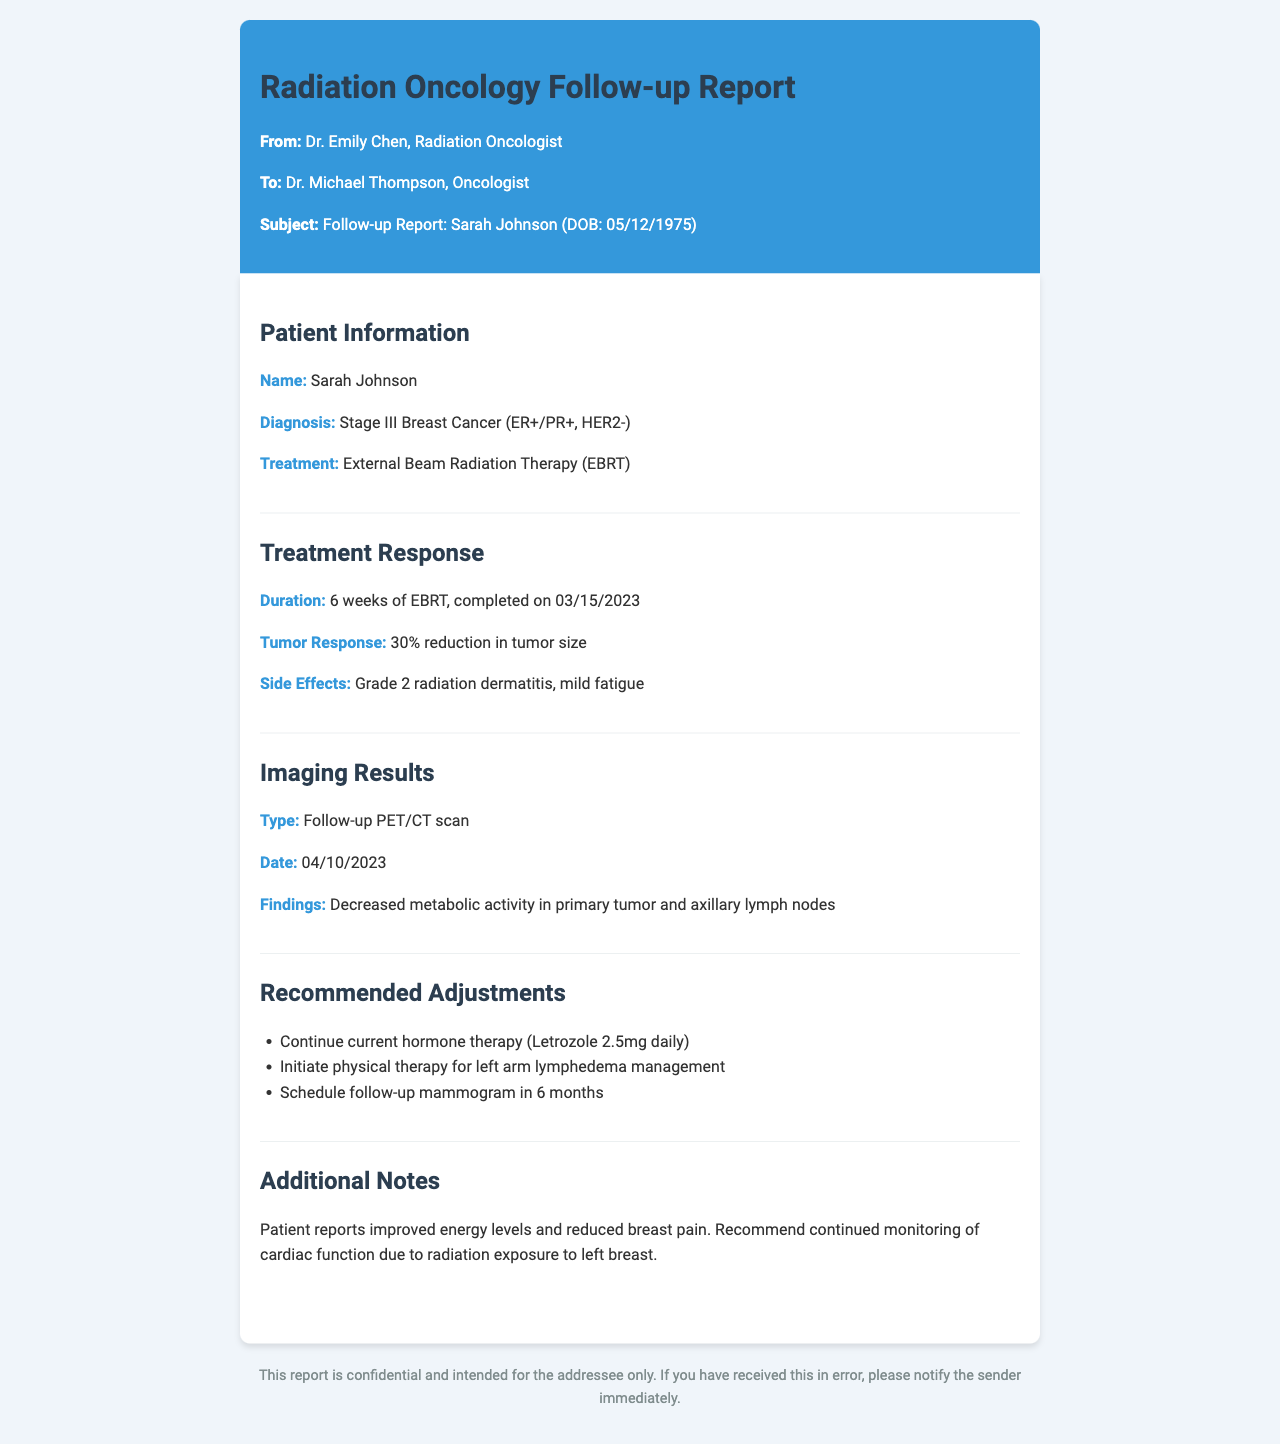What is the patient's name? The patient's name is mentioned in the patient information section of the report.
Answer: Sarah Johnson What is the diagnosis? The diagnosis is specified in the patient information section of the report.
Answer: Stage III Breast Cancer (ER+/PR+, HER2-) What treatment did the patient undergo? The treatment is listed under patient information in the report.
Answer: External Beam Radiation Therapy (EBRT) What was the duration of the treatment? The duration of the treatment is provided in the treatment response section of the report.
Answer: 6 weeks What percentage did the tumor reduce in size? The tumor response specifies the percentage reduction in the treatment response section.
Answer: 30% What side effects did the patient experience? The side effects the patient experienced are indicated in the treatment response section.
Answer: Grade 2 radiation dermatitis, mild fatigue What imaging type was performed? The type of imaging is described in the imaging results section of the report.
Answer: Follow-up PET/CT scan What is one recommended adjustment to the care plan? Recommended adjustments are listed in their own section of the report.
Answer: Continue current hormone therapy (Letrozole 2.5mg daily) When should the follow-up mammogram be scheduled? The timing for the follow-up mammogram is mentioned in the recommended adjustments section.
Answer: In 6 months What additional note was made regarding the patient's condition? The additional notes section contains remarks on the patient's condition.
Answer: Recommend continued monitoring of cardiac function due to radiation exposure to left breast 